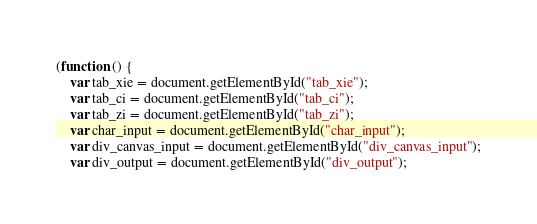<code> <loc_0><loc_0><loc_500><loc_500><_JavaScript_>(function () {
	var tab_xie = document.getElementById("tab_xie");
	var tab_ci = document.getElementById("tab_ci");
	var tab_zi = document.getElementById("tab_zi");
	var char_input = document.getElementById("char_input");
	var div_canvas_input = document.getElementById("div_canvas_input");
	var div_output = document.getElementById("div_output");</code> 